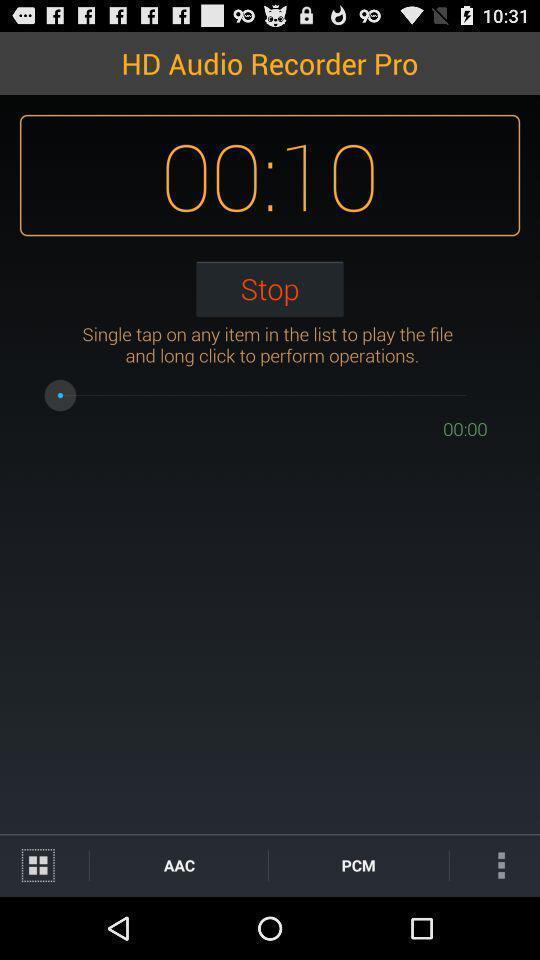Summarize the information in this screenshot. Screen displaying the recording timer. 